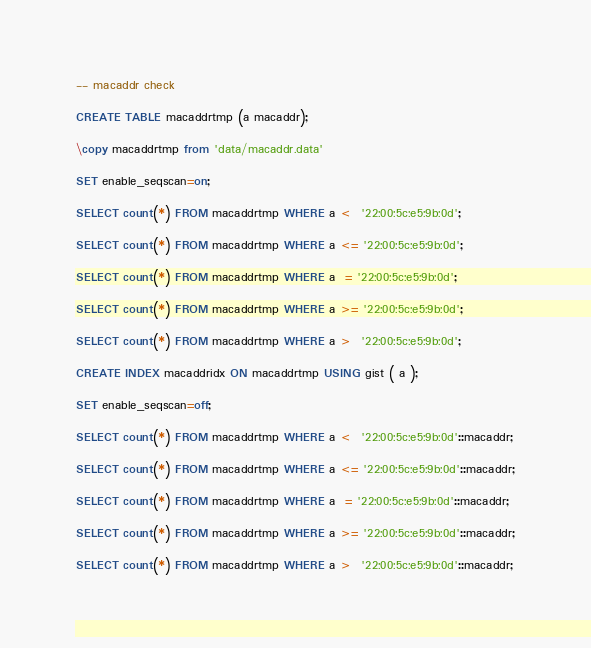<code> <loc_0><loc_0><loc_500><loc_500><_SQL_>-- macaddr check

CREATE TABLE macaddrtmp (a macaddr);

\copy macaddrtmp from 'data/macaddr.data'

SET enable_seqscan=on;

SELECT count(*) FROM macaddrtmp WHERE a <  '22:00:5c:e5:9b:0d';

SELECT count(*) FROM macaddrtmp WHERE a <= '22:00:5c:e5:9b:0d';

SELECT count(*) FROM macaddrtmp WHERE a  = '22:00:5c:e5:9b:0d';

SELECT count(*) FROM macaddrtmp WHERE a >= '22:00:5c:e5:9b:0d';

SELECT count(*) FROM macaddrtmp WHERE a >  '22:00:5c:e5:9b:0d';

CREATE INDEX macaddridx ON macaddrtmp USING gist ( a );

SET enable_seqscan=off;

SELECT count(*) FROM macaddrtmp WHERE a <  '22:00:5c:e5:9b:0d'::macaddr;

SELECT count(*) FROM macaddrtmp WHERE a <= '22:00:5c:e5:9b:0d'::macaddr;

SELECT count(*) FROM macaddrtmp WHERE a  = '22:00:5c:e5:9b:0d'::macaddr;

SELECT count(*) FROM macaddrtmp WHERE a >= '22:00:5c:e5:9b:0d'::macaddr;

SELECT count(*) FROM macaddrtmp WHERE a >  '22:00:5c:e5:9b:0d'::macaddr;
</code> 